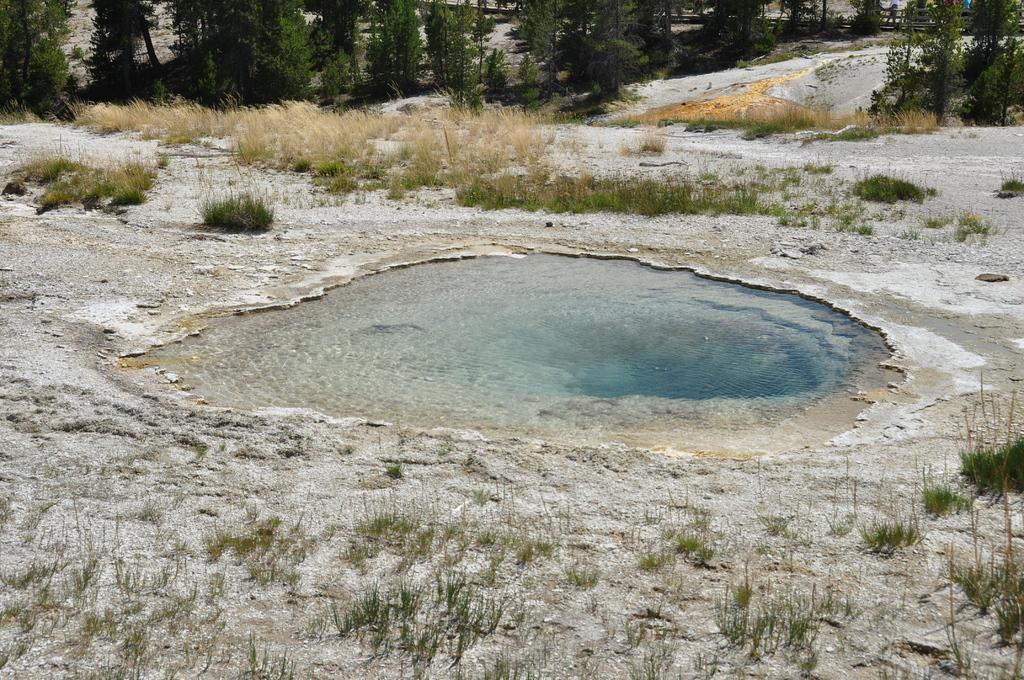What is located in the middle of the image? There is water in the middle of the image. What can be seen around the water? There are plants and trees around the water. What is visible on the ground around the water? The ground is visible around the water. What type of toothbrush is being used to stir the stew in the image? There is no toothbrush or stew present in the image; it features water surrounded by plants, trees, and the ground. 